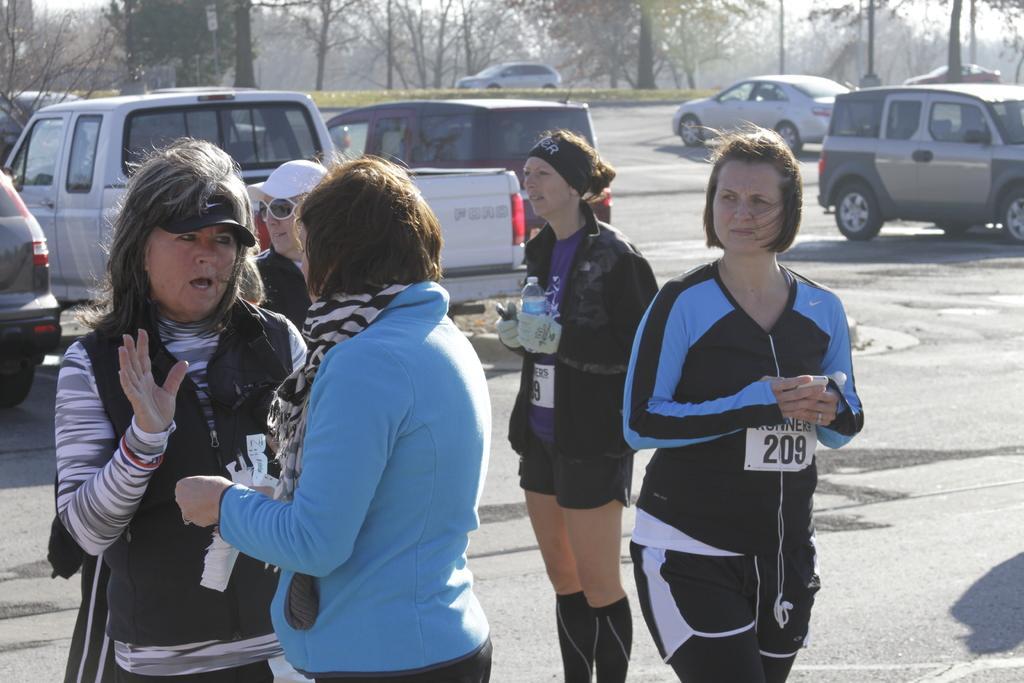Describe this image in one or two sentences. In this image we can see many people. There are many vehicles in the image. There is a sky in the image. There is a road in the image. There are few people holding some objects in their hands. There are many trees in the image. 